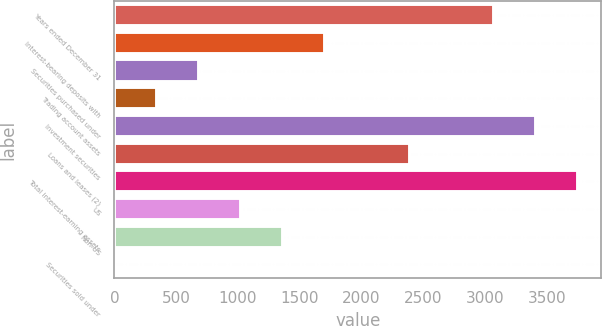<chart> <loc_0><loc_0><loc_500><loc_500><bar_chart><fcel>Years ended December 31<fcel>Interest-bearing deposits with<fcel>Securities purchased under<fcel>Trading account assets<fcel>Investment securities<fcel>Loans and leases (2)<fcel>Total interest-earning assets<fcel>US<fcel>Non-US<fcel>Securities sold under<nl><fcel>3071.1<fcel>1707.5<fcel>684.8<fcel>343.9<fcel>3412<fcel>2389.3<fcel>3752.9<fcel>1025.7<fcel>1366.6<fcel>3<nl></chart> 